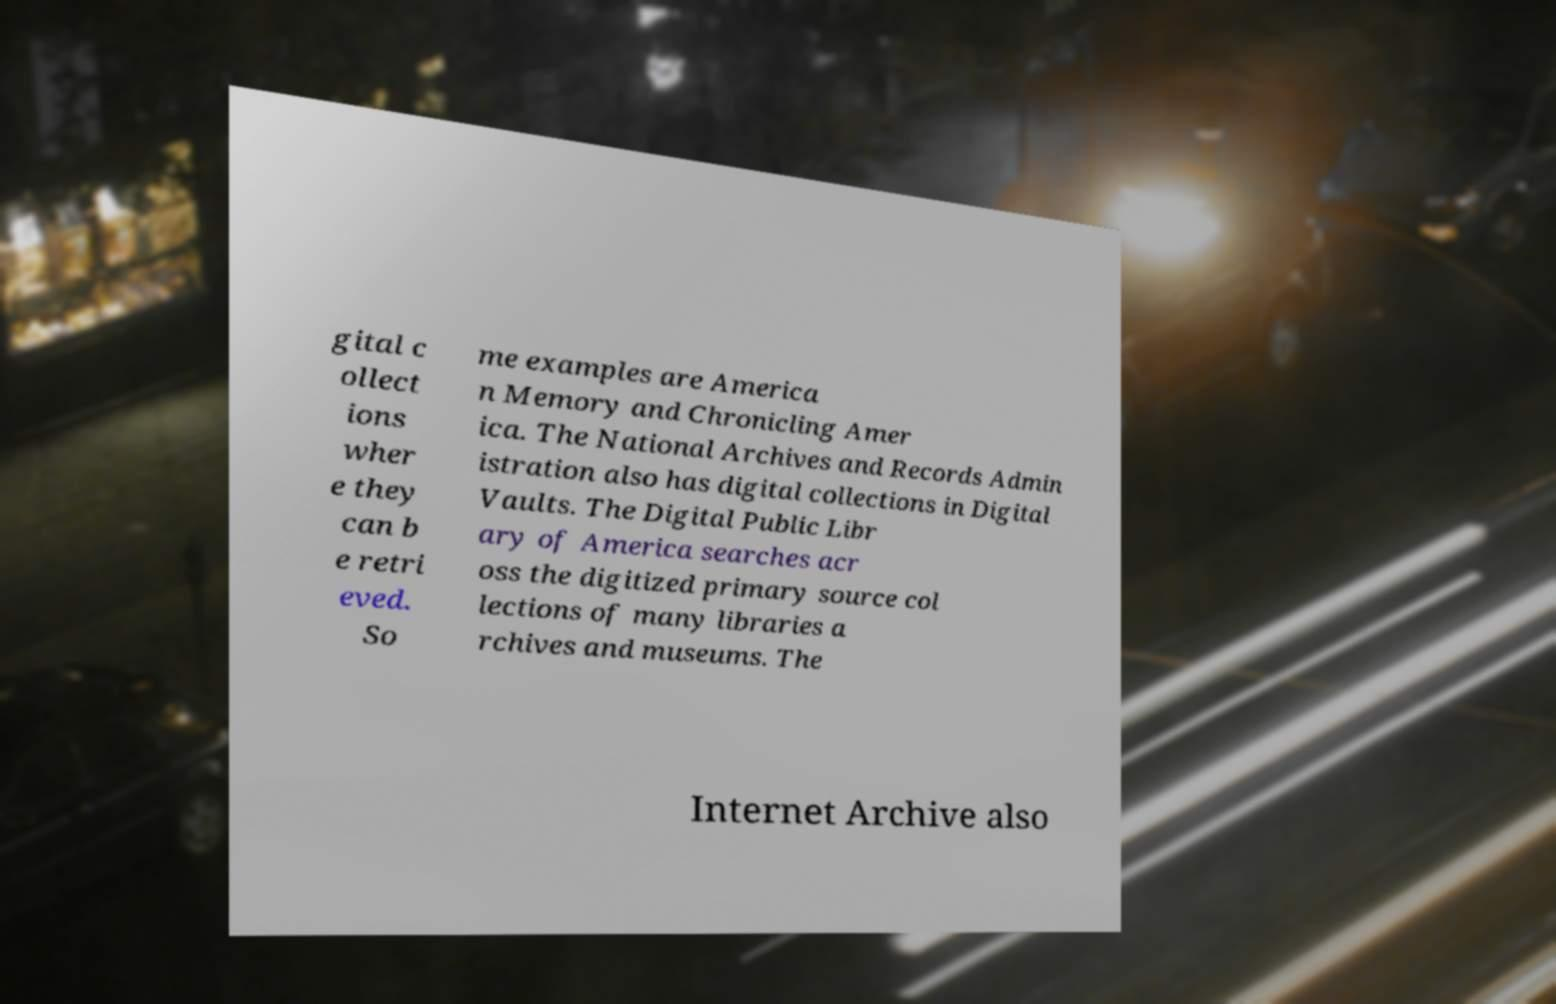Can you accurately transcribe the text from the provided image for me? gital c ollect ions wher e they can b e retri eved. So me examples are America n Memory and Chronicling Amer ica. The National Archives and Records Admin istration also has digital collections in Digital Vaults. The Digital Public Libr ary of America searches acr oss the digitized primary source col lections of many libraries a rchives and museums. The Internet Archive also 